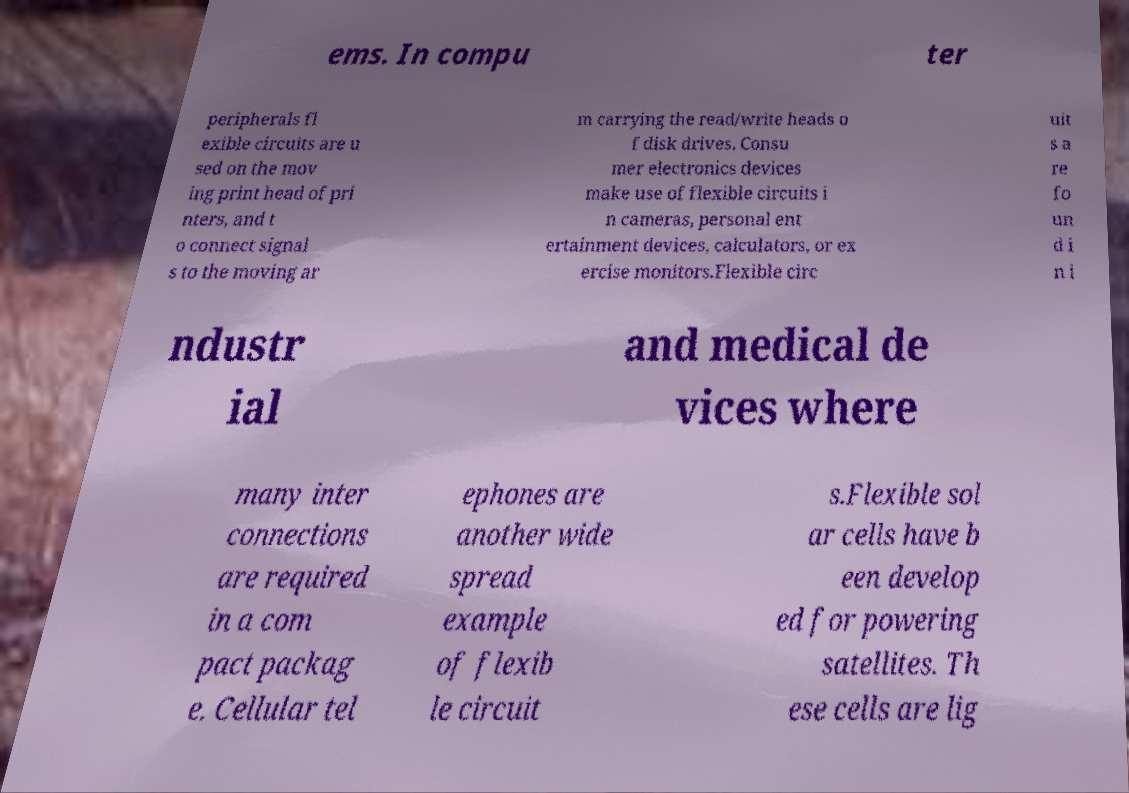Can you accurately transcribe the text from the provided image for me? ems. In compu ter peripherals fl exible circuits are u sed on the mov ing print head of pri nters, and t o connect signal s to the moving ar m carrying the read/write heads o f disk drives. Consu mer electronics devices make use of flexible circuits i n cameras, personal ent ertainment devices, calculators, or ex ercise monitors.Flexible circ uit s a re fo un d i n i ndustr ial and medical de vices where many inter connections are required in a com pact packag e. Cellular tel ephones are another wide spread example of flexib le circuit s.Flexible sol ar cells have b een develop ed for powering satellites. Th ese cells are lig 